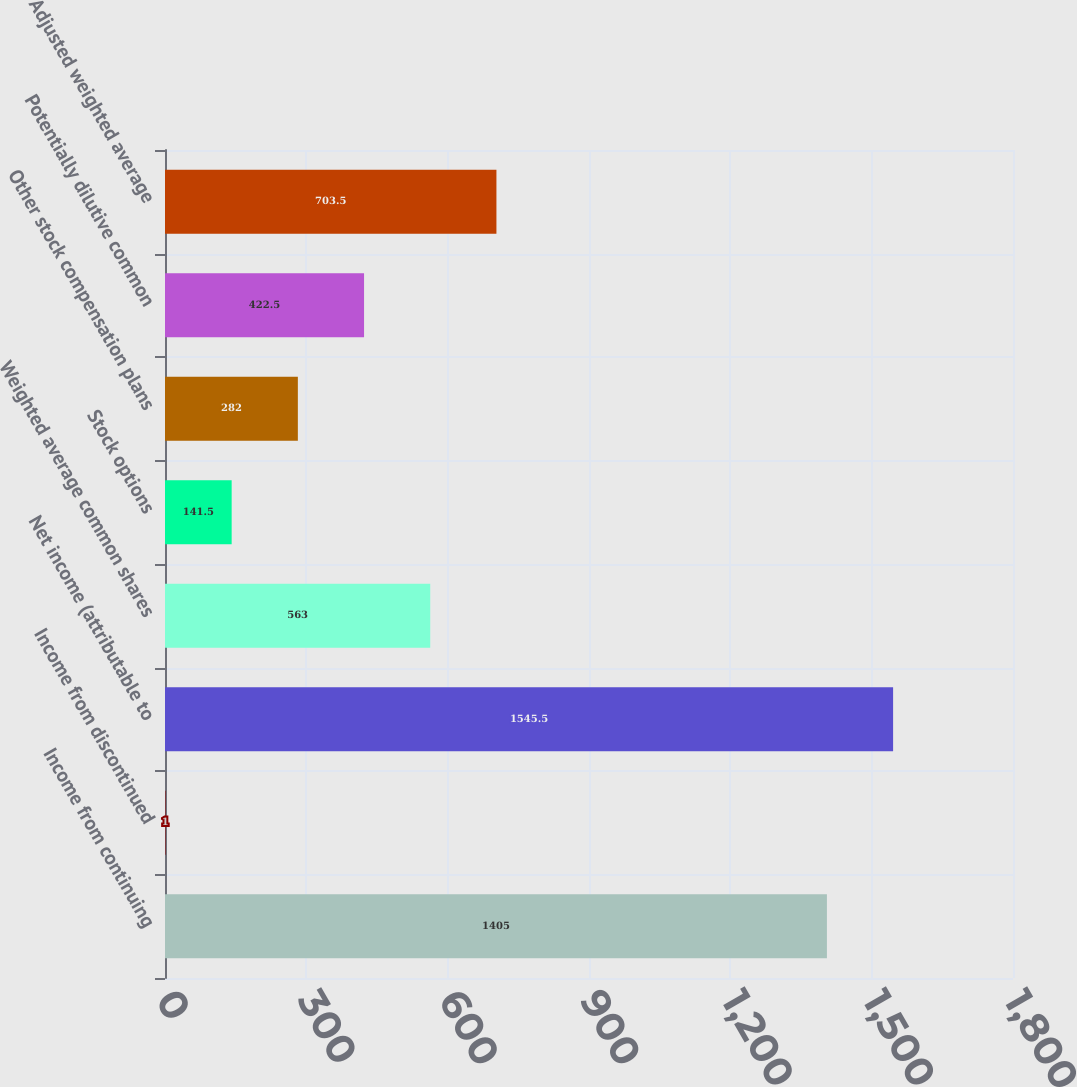<chart> <loc_0><loc_0><loc_500><loc_500><bar_chart><fcel>Income from continuing<fcel>Income from discontinued<fcel>Net income (attributable to<fcel>Weighted average common shares<fcel>Stock options<fcel>Other stock compensation plans<fcel>Potentially dilutive common<fcel>Adjusted weighted average<nl><fcel>1405<fcel>1<fcel>1545.5<fcel>563<fcel>141.5<fcel>282<fcel>422.5<fcel>703.5<nl></chart> 